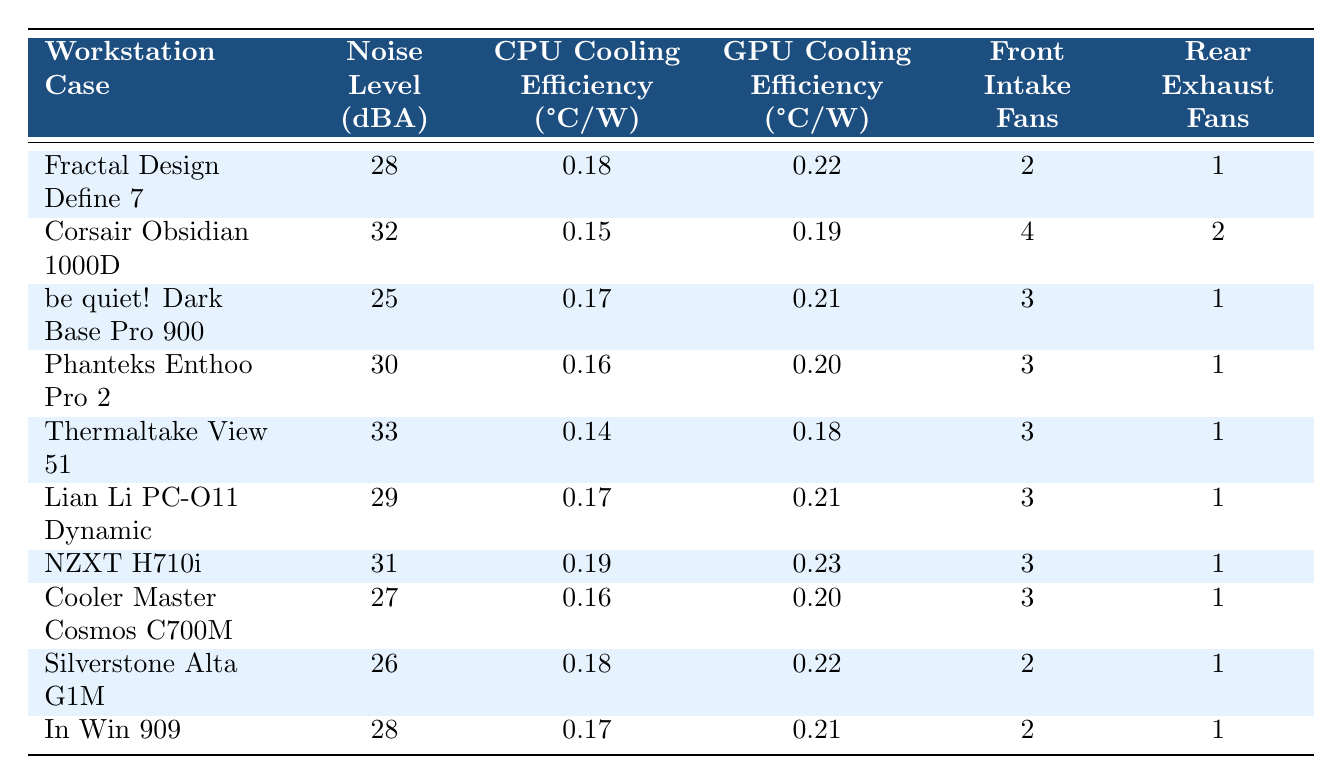What is the noise level of the Fractal Design Define 7? The noise level is directly provided in the table for each case. For the Fractal Design Define 7, the value listed in the corresponding row is 28 dBA.
Answer: 28 dBA Which workstation case has the lowest noise level? By examining the noise levels in the table, the lowest value is found in the row for be quiet! Dark Base Pro 900, which shows a noise level of 25 dBA.
Answer: be quiet! Dark Base Pro 900 How many front intake fans does the Corsair Obsidian 1000D have? The table lists the number of front intake fans for each workstation case, and for the Corsair Obsidian 1000D, the corresponding value is 4.
Answer: 4 What is the average CPU cooling efficiency of all workstation cases? To find the average, sum the CPU cooling efficiencies: (0.18 + 0.15 + 0.17 + 0.16 + 0.14 + 0.17 + 0.19 + 0.16 + 0.18 + 0.17) = 1.71. Then divide by the number of cases (10): 1.71/10 = 0.171.
Answer: 0.171 °C/W How does the GPU cooling efficiency of the Thermaltake View 51 compare to the Lian Li PC-O11 Dynamic? The GPU cooling efficiency for the Thermaltake View 51 is 0.18 °C/W, while for the Lian Li PC-O11 Dynamic, it is 0.21 °C/W. Since 0.21 is greater than 0.18, the Lian Li case has better GPU cooling efficiency.
Answer: Lian Li PC-O11 Dynamic has better efficiency Is the noise level of the NZXT H710i the same as the Fractal Design Define 7? The NZXT H710i has a noise level of 31 dBA, while the Fractal Design Define 7 has a noise level of 28 dBA. Since 31 is not equal to 28, the statement is false.
Answer: No What is the difference in noise level between the loudest and quietest workstation cases? The loudest case, Thermaltake View 51, has a noise level of 33 dBA, and the quietest case, be quiet! Dark Base Pro 900, has a noise level of 25 dBA. The difference is calculated as 33 - 25 = 8 dBA.
Answer: 8 dBA If you wanted to minimize noise while maximizing cooling efficiency, which case would you choose based on the data? Based on the data, the best option is the be quiet! Dark Base Pro 900 as it has the lowest noise level (25 dBA) and a reasonable CPU cooling efficiency of 0.17 °C/W.
Answer: be quiet! Dark Base Pro 900 What is the total number of fans (front intake + rear exhaust) in the Cooler Master Cosmos C700M? The Cooler Master Cosmos C700M has 3 front intake fans and 1 rear exhaust fan. Adding these together gives a total of 3 + 1 = 4 fans.
Answer: 4 fans Are there more cases with a noise level above 30 dBA or below 30 dBA? Looking at the table, the cases Corsair Obsidian 1000D, Thermaltake View 51, and NZXT H710i all have noise levels above 30 dBA (3 cases). The others (Fractal Design Define 7, be quiet! Dark Base Pro 900, Phanteks Enthoo Pro 2, Lian Li PC-O11 Dynamic, Cooler Master Cosmos C700M, Silverstone Alta G1M, In Win 909) have levels below 30 dBA (7 cases). Therefore, there are more cases below 30 dBA.
Answer: Below 30 dBA Does the number of fans in a case correlate with its noise level based on the data? The data shows a range of noise levels across cases with differing numbers of fans, and while some high-fan cases have high noise levels (such as Corsair Obsidian 1000D), others with fewer fans also maintain low noise (like the Cooler Master Cosmos C700M). Because of the variance, it suggests no clear correlation.
Answer: No clear correlation 